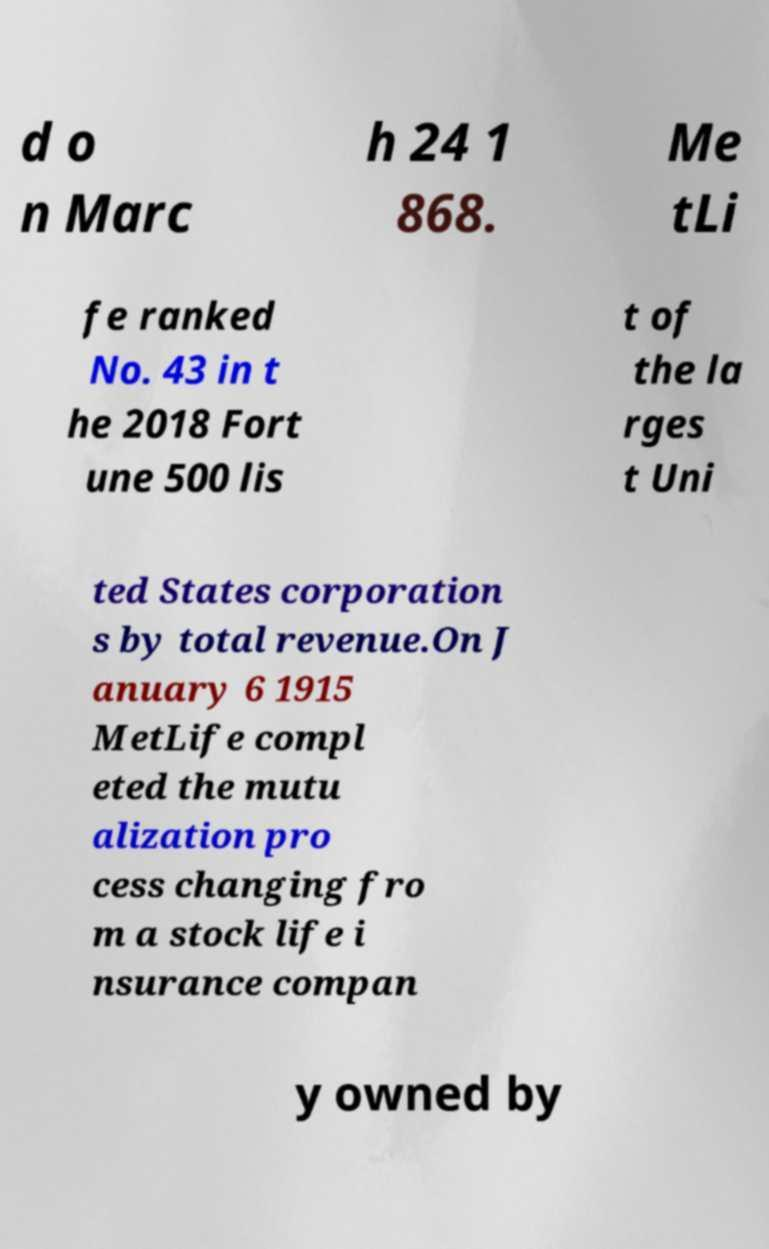Could you assist in decoding the text presented in this image and type it out clearly? d o n Marc h 24 1 868. Me tLi fe ranked No. 43 in t he 2018 Fort une 500 lis t of the la rges t Uni ted States corporation s by total revenue.On J anuary 6 1915 MetLife compl eted the mutu alization pro cess changing fro m a stock life i nsurance compan y owned by 